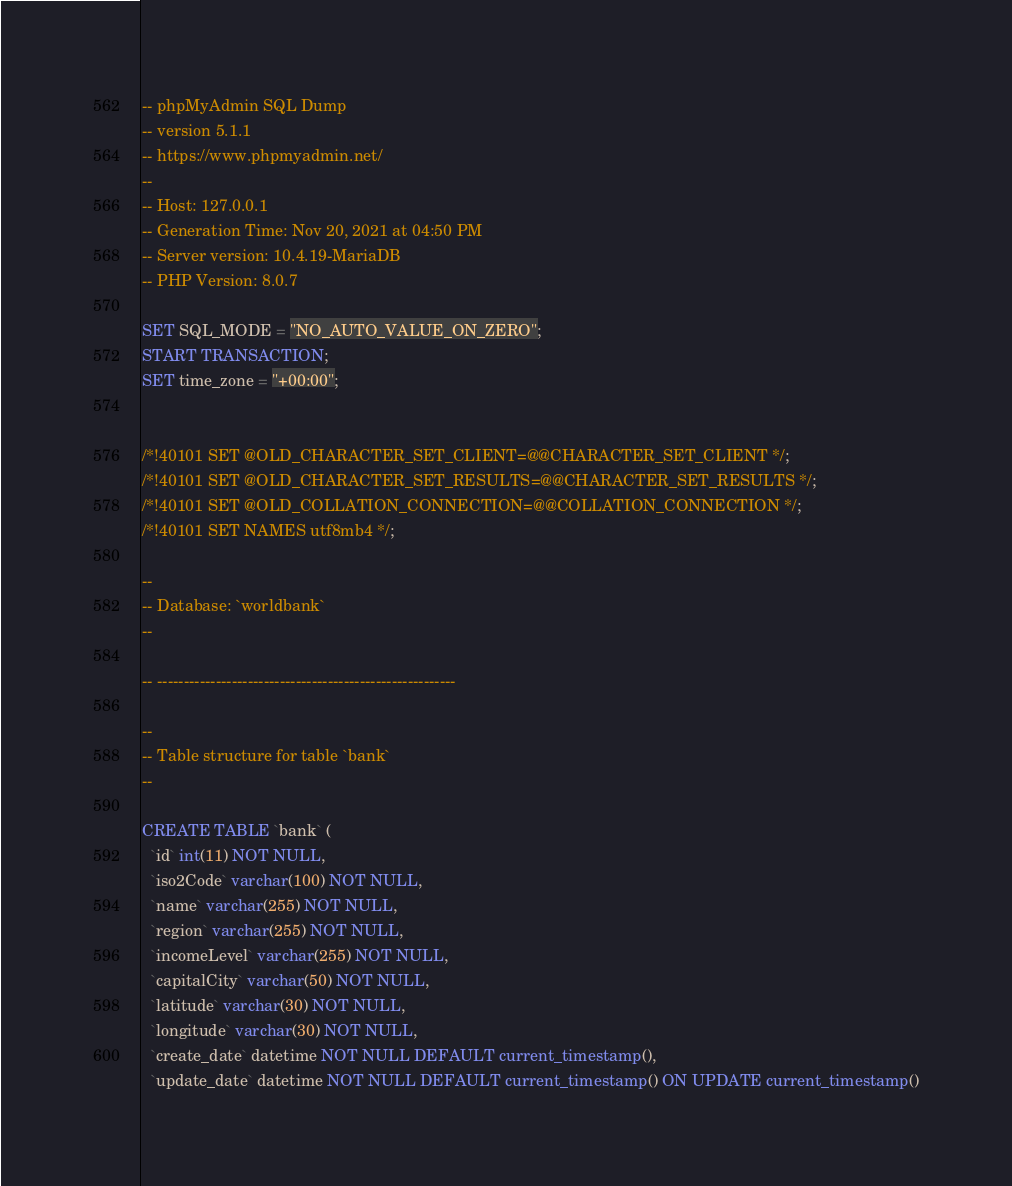Convert code to text. <code><loc_0><loc_0><loc_500><loc_500><_SQL_>-- phpMyAdmin SQL Dump
-- version 5.1.1
-- https://www.phpmyadmin.net/
--
-- Host: 127.0.0.1
-- Generation Time: Nov 20, 2021 at 04:50 PM
-- Server version: 10.4.19-MariaDB
-- PHP Version: 8.0.7

SET SQL_MODE = "NO_AUTO_VALUE_ON_ZERO";
START TRANSACTION;
SET time_zone = "+00:00";


/*!40101 SET @OLD_CHARACTER_SET_CLIENT=@@CHARACTER_SET_CLIENT */;
/*!40101 SET @OLD_CHARACTER_SET_RESULTS=@@CHARACTER_SET_RESULTS */;
/*!40101 SET @OLD_COLLATION_CONNECTION=@@COLLATION_CONNECTION */;
/*!40101 SET NAMES utf8mb4 */;

--
-- Database: `worldbank`
--

-- --------------------------------------------------------

--
-- Table structure for table `bank`
--

CREATE TABLE `bank` (
  `id` int(11) NOT NULL,
  `iso2Code` varchar(100) NOT NULL,
  `name` varchar(255) NOT NULL,
  `region` varchar(255) NOT NULL,
  `incomeLevel` varchar(255) NOT NULL,
  `capitalCity` varchar(50) NOT NULL,
  `latitude` varchar(30) NOT NULL,
  `longitude` varchar(30) NOT NULL,
  `create_date` datetime NOT NULL DEFAULT current_timestamp(),
  `update_date` datetime NOT NULL DEFAULT current_timestamp() ON UPDATE current_timestamp()</code> 